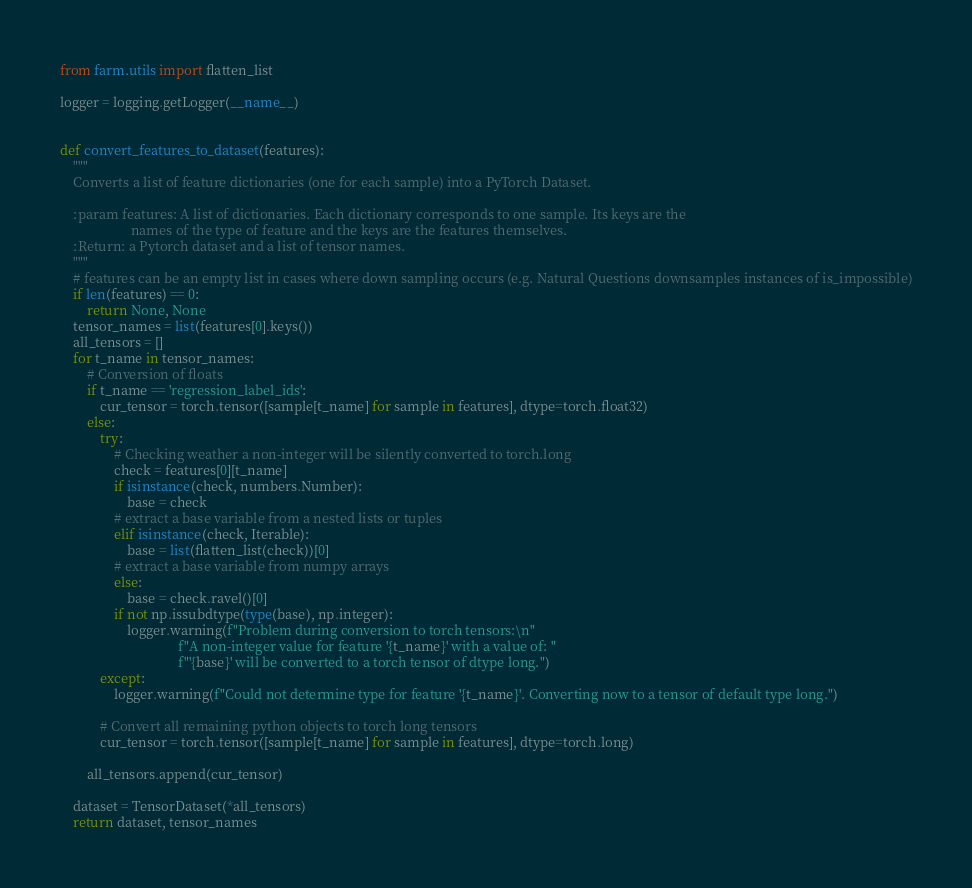<code> <loc_0><loc_0><loc_500><loc_500><_Python_>from farm.utils import flatten_list

logger = logging.getLogger(__name__)


def convert_features_to_dataset(features):
    """
    Converts a list of feature dictionaries (one for each sample) into a PyTorch Dataset.

    :param features: A list of dictionaries. Each dictionary corresponds to one sample. Its keys are the
                     names of the type of feature and the keys are the features themselves.
    :Return: a Pytorch dataset and a list of tensor names.
    """
    # features can be an empty list in cases where down sampling occurs (e.g. Natural Questions downsamples instances of is_impossible)
    if len(features) == 0:
        return None, None
    tensor_names = list(features[0].keys())
    all_tensors = []
    for t_name in tensor_names:
        # Conversion of floats
        if t_name == 'regression_label_ids':
            cur_tensor = torch.tensor([sample[t_name] for sample in features], dtype=torch.float32)
        else:
            try:
                # Checking weather a non-integer will be silently converted to torch.long
                check = features[0][t_name]
                if isinstance(check, numbers.Number):
                    base = check
                # extract a base variable from a nested lists or tuples
                elif isinstance(check, Iterable):
                    base = list(flatten_list(check))[0]
                # extract a base variable from numpy arrays
                else:
                    base = check.ravel()[0]
                if not np.issubdtype(type(base), np.integer):
                    logger.warning(f"Problem during conversion to torch tensors:\n"
                                   f"A non-integer value for feature '{t_name}' with a value of: "
                                   f"'{base}' will be converted to a torch tensor of dtype long.")
            except:
                logger.warning(f"Could not determine type for feature '{t_name}'. Converting now to a tensor of default type long.")

            # Convert all remaining python objects to torch long tensors
            cur_tensor = torch.tensor([sample[t_name] for sample in features], dtype=torch.long)

        all_tensors.append(cur_tensor)

    dataset = TensorDataset(*all_tensors)
    return dataset, tensor_names</code> 